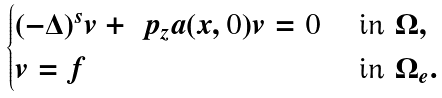<formula> <loc_0><loc_0><loc_500><loc_500>\begin{cases} ( - \Delta ) ^ { s } v + \ p _ { z } a ( x , 0 ) v = 0 & \text { in } \Omega , \\ v = f & \text { in } \Omega _ { e } . \end{cases}</formula> 